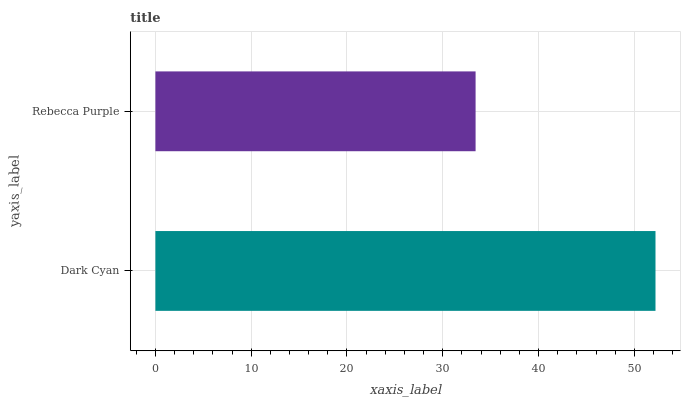Is Rebecca Purple the minimum?
Answer yes or no. Yes. Is Dark Cyan the maximum?
Answer yes or no. Yes. Is Rebecca Purple the maximum?
Answer yes or no. No. Is Dark Cyan greater than Rebecca Purple?
Answer yes or no. Yes. Is Rebecca Purple less than Dark Cyan?
Answer yes or no. Yes. Is Rebecca Purple greater than Dark Cyan?
Answer yes or no. No. Is Dark Cyan less than Rebecca Purple?
Answer yes or no. No. Is Dark Cyan the high median?
Answer yes or no. Yes. Is Rebecca Purple the low median?
Answer yes or no. Yes. Is Rebecca Purple the high median?
Answer yes or no. No. Is Dark Cyan the low median?
Answer yes or no. No. 